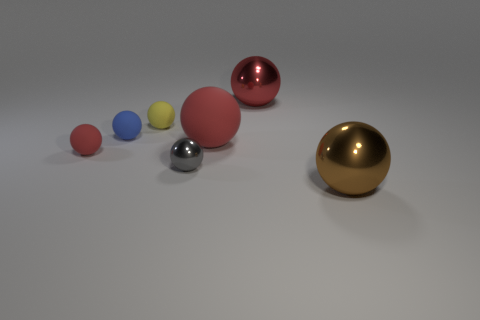Is the number of blue balls less than the number of tiny purple cubes?
Provide a succinct answer. No. How many objects are either small yellow matte objects or metal balls behind the yellow thing?
Give a very brief answer. 2. Are there any small balls made of the same material as the big brown sphere?
Your answer should be very brief. Yes. There is a yellow object that is the same size as the gray ball; what material is it?
Make the answer very short. Rubber. What material is the blue thing that is behind the large red sphere to the left of the big red metal object?
Your answer should be very brief. Rubber. There is a metallic thing to the left of the big red metal ball; does it have the same shape as the brown object?
Provide a succinct answer. Yes. What color is the other big sphere that is made of the same material as the blue ball?
Keep it short and to the point. Red. What is the material of the red sphere that is to the left of the yellow object?
Offer a terse response. Rubber. There is a large brown shiny thing; does it have the same shape as the big metal object behind the brown ball?
Offer a very short reply. Yes. There is a red sphere that is on the right side of the gray thing and in front of the blue thing; what material is it?
Your answer should be compact. Rubber. 